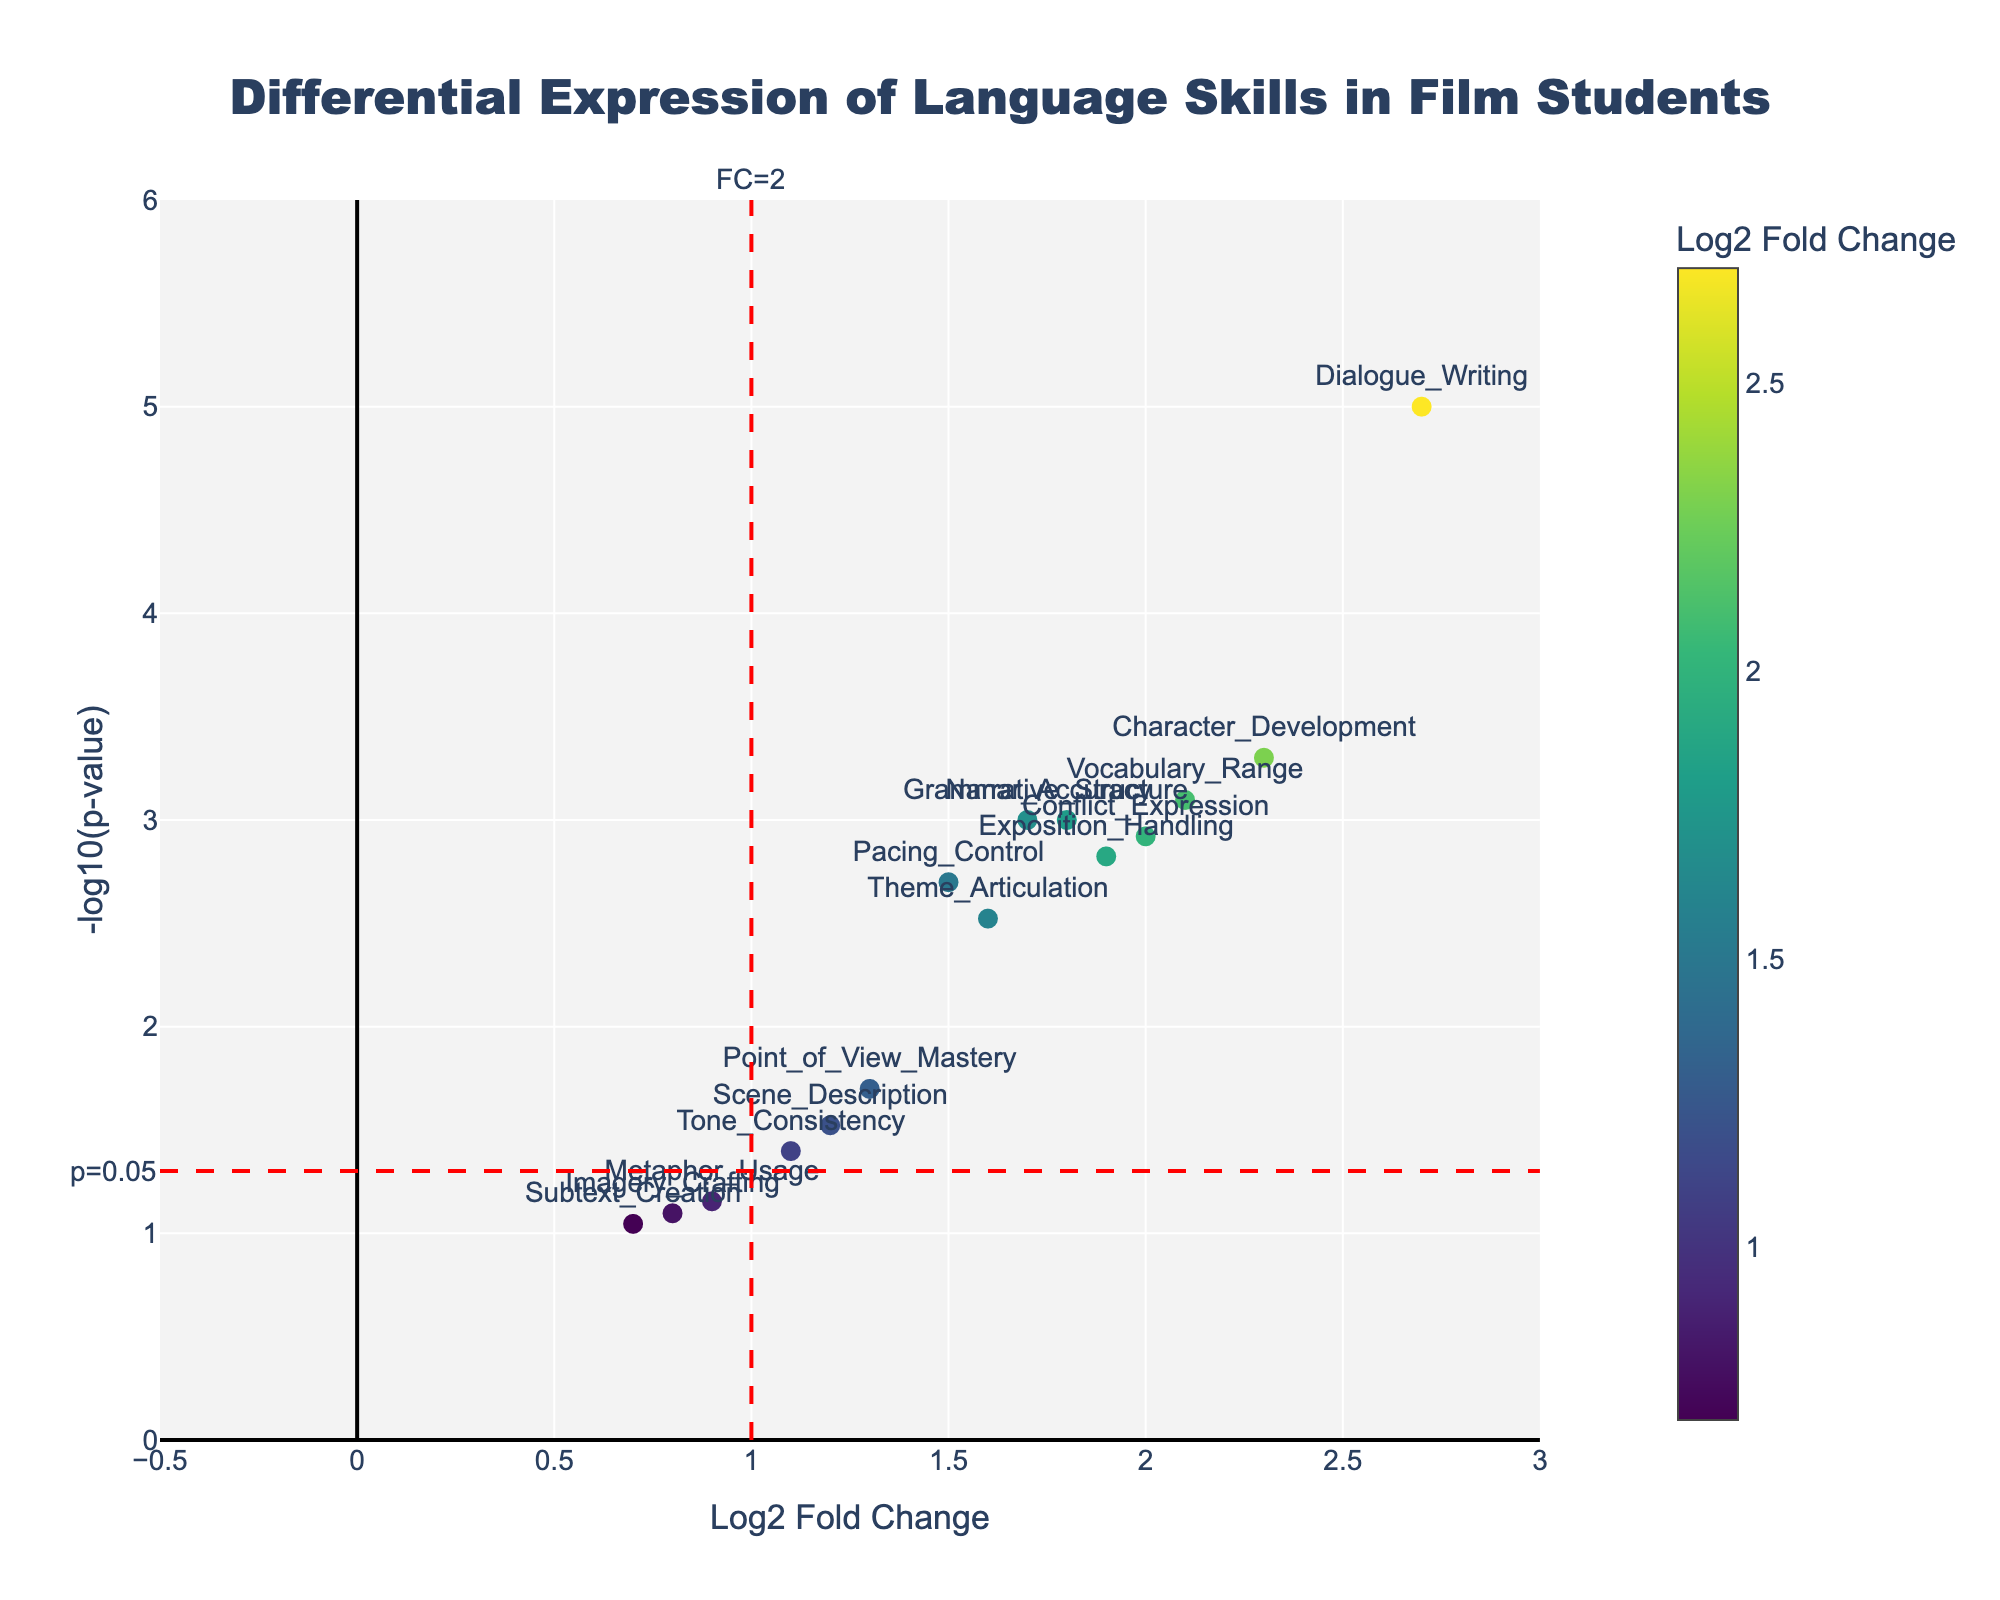What is the title of the plot? Look for the text at the top center of the plot that usually describes the purpose or content of the figure.
Answer: Differential Expression of Language Skills in Film Students How many data points (skills) are displayed in the plot? Count the number of markers visible on the plot. Each marker represents a different skill.
Answer: 15 Which skill shows the highest -log10(p-value)? Identify the skill corresponding to the highest point on the y-axis, which represents the highest -log10(p-value).
Answer: Dialogue_Writing Which skills have a Log2 Fold Change greater than 2? Look for markers positioned to the right of the vertical line at Log2 Fold Change = 2 and check their corresponding labels.
Answer: Character_Development, Dialogue_Writing, Vocabulary_Range, Conflict_Expression What is the color scale used for the markers? Observe the color bar on the right side of the plot which indicates the range of colors used based on Log2 Fold Change values.
Answer: Viridis Which skill has the lowest -log10(p-value) but is still greater than 0? Find the marker with the lowest position just above the x-axis and identify its label.
Answer: Metaphor_Usage Are there any skills with a Log2 Fold Change between 0.5 and 1 and a -log10(p-value) greater than 1? Check for markers positioned horizontally between 0.5 and 1 on the x-axis and vertically above 1 on the y-axis, then note their corresponding labels.
Answer: Metaphor_Usage, Subtext_Creation, Imagery_Crafting What are the significance lines, and what do they indicate? Identify the dashed lines on the plot and read their annotations to understand what thresholds they represent.
Answer: The horizontal line at -log10(p-value) = -log10(0.05) indicates statistical significance at p = 0.05, and the vertical line at Log2 Fold Change = 1 indicates a fold change threshold of 2 Which skill has a Log2 Fold Change of 1.2 and what’s its -log10(p-value)? Find the marker positioned horizontally at 1.2 on the x-axis and identify its vertical position on the y-axis, then note its corresponding label and value.
Answer: Scene_Description, about 1.52 